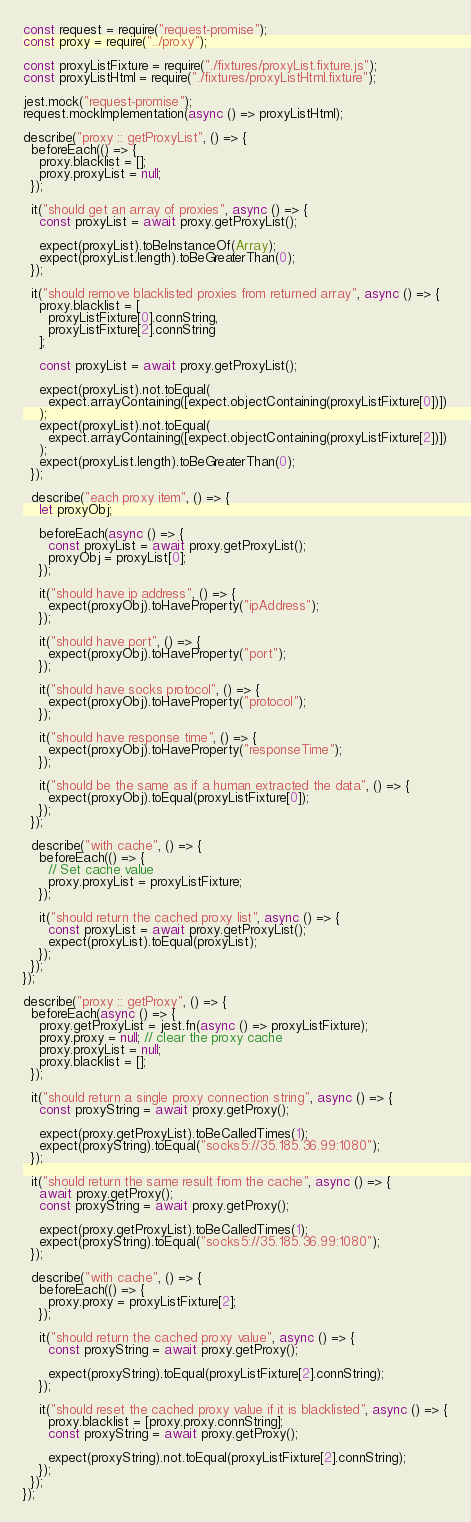Convert code to text. <code><loc_0><loc_0><loc_500><loc_500><_JavaScript_>const request = require("request-promise");
const proxy = require("../proxy");

const proxyListFixture = require("./fixtures/proxyList.fixture.js");
const proxyListHtml = require("./fixtures/proxyListHtml.fixture");

jest.mock("request-promise");
request.mockImplementation(async () => proxyListHtml);

describe("proxy :: getProxyList", () => {
  beforeEach(() => {
    proxy.blacklist = [];
    proxy.proxyList = null;
  });

  it("should get an array of proxies", async () => {
    const proxyList = await proxy.getProxyList();

    expect(proxyList).toBeInstanceOf(Array);
    expect(proxyList.length).toBeGreaterThan(0);
  });

  it("should remove blacklisted proxies from returned array", async () => {
    proxy.blacklist = [
      proxyListFixture[0].connString,
      proxyListFixture[2].connString
    ];

    const proxyList = await proxy.getProxyList();

    expect(proxyList).not.toEqual(
      expect.arrayContaining([expect.objectContaining(proxyListFixture[0])])
    );
    expect(proxyList).not.toEqual(
      expect.arrayContaining([expect.objectContaining(proxyListFixture[2])])
    );
    expect(proxyList.length).toBeGreaterThan(0);
  });

  describe("each proxy item", () => {
    let proxyObj;

    beforeEach(async () => {
      const proxyList = await proxy.getProxyList();
      proxyObj = proxyList[0];
    });

    it("should have ip address", () => {
      expect(proxyObj).toHaveProperty("ipAddress");
    });

    it("should have port", () => {
      expect(proxyObj).toHaveProperty("port");
    });

    it("should have socks protocol", () => {
      expect(proxyObj).toHaveProperty("protocol");
    });

    it("should have response time", () => {
      expect(proxyObj).toHaveProperty("responseTime");
    });

    it("should be the same as if a human extracted the data", () => {
      expect(proxyObj).toEqual(proxyListFixture[0]);
    });
  });

  describe("with cache", () => {
    beforeEach(() => {
      // Set cache value
      proxy.proxyList = proxyListFixture;
    });

    it("should return the cached proxy list", async () => {
      const proxyList = await proxy.getProxyList();
      expect(proxyList).toEqual(proxyList);
    });
  });
});

describe("proxy :: getProxy", () => {
  beforeEach(async () => {
    proxy.getProxyList = jest.fn(async () => proxyListFixture);
    proxy.proxy = null; // clear the proxy cache
    proxy.proxyList = null;
    proxy.blacklist = [];
  });

  it("should return a single proxy connection string", async () => {
    const proxyString = await proxy.getProxy();

    expect(proxy.getProxyList).toBeCalledTimes(1);
    expect(proxyString).toEqual("socks5://35.185.36.99:1080");
  });

  it("should return the same result from the cache", async () => {
    await proxy.getProxy();
    const proxyString = await proxy.getProxy();

    expect(proxy.getProxyList).toBeCalledTimes(1);
    expect(proxyString).toEqual("socks5://35.185.36.99:1080");
  });

  describe("with cache", () => {
    beforeEach(() => {
      proxy.proxy = proxyListFixture[2];
    });

    it("should return the cached proxy value", async () => {
      const proxyString = await proxy.getProxy();

      expect(proxyString).toEqual(proxyListFixture[2].connString);
    });

    it("should reset the cached proxy value if it is blacklisted", async () => {
      proxy.blacklist = [proxy.proxy.connString];
      const proxyString = await proxy.getProxy();

      expect(proxyString).not.toEqual(proxyListFixture[2].connString);
    });
  });
});
</code> 